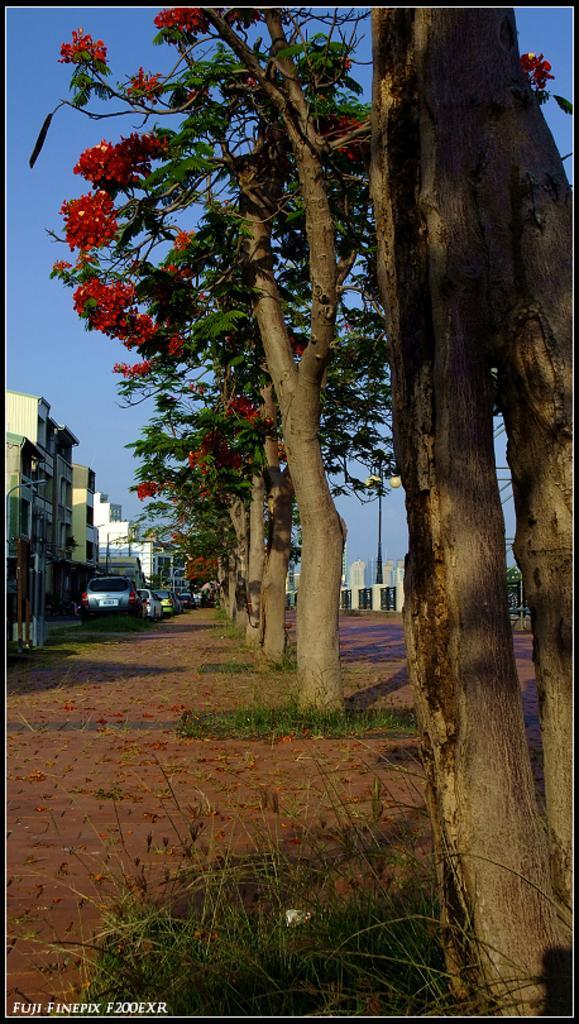Could you give a brief overview of what you see in this image? In this image I can see the ground, some grass on the ground, few trees which are brown and green in color and few flowers to the trees which are red in color. I can see few vehicles and few buildings. In the background I can see the sky. 